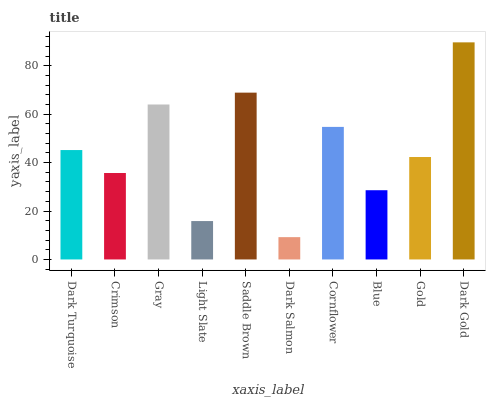Is Crimson the minimum?
Answer yes or no. No. Is Crimson the maximum?
Answer yes or no. No. Is Dark Turquoise greater than Crimson?
Answer yes or no. Yes. Is Crimson less than Dark Turquoise?
Answer yes or no. Yes. Is Crimson greater than Dark Turquoise?
Answer yes or no. No. Is Dark Turquoise less than Crimson?
Answer yes or no. No. Is Dark Turquoise the high median?
Answer yes or no. Yes. Is Gold the low median?
Answer yes or no. Yes. Is Gold the high median?
Answer yes or no. No. Is Dark Salmon the low median?
Answer yes or no. No. 